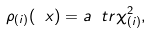Convert formula to latex. <formula><loc_0><loc_0><loc_500><loc_500>\rho _ { ( i ) } ( \ x ) = a \ t r \chi _ { ( i ) } ^ { 2 } ,</formula> 